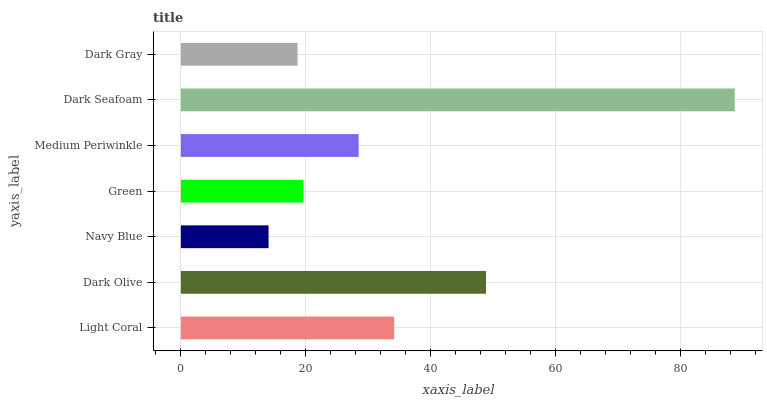Is Navy Blue the minimum?
Answer yes or no. Yes. Is Dark Seafoam the maximum?
Answer yes or no. Yes. Is Dark Olive the minimum?
Answer yes or no. No. Is Dark Olive the maximum?
Answer yes or no. No. Is Dark Olive greater than Light Coral?
Answer yes or no. Yes. Is Light Coral less than Dark Olive?
Answer yes or no. Yes. Is Light Coral greater than Dark Olive?
Answer yes or no. No. Is Dark Olive less than Light Coral?
Answer yes or no. No. Is Medium Periwinkle the high median?
Answer yes or no. Yes. Is Medium Periwinkle the low median?
Answer yes or no. Yes. Is Green the high median?
Answer yes or no. No. Is Dark Gray the low median?
Answer yes or no. No. 